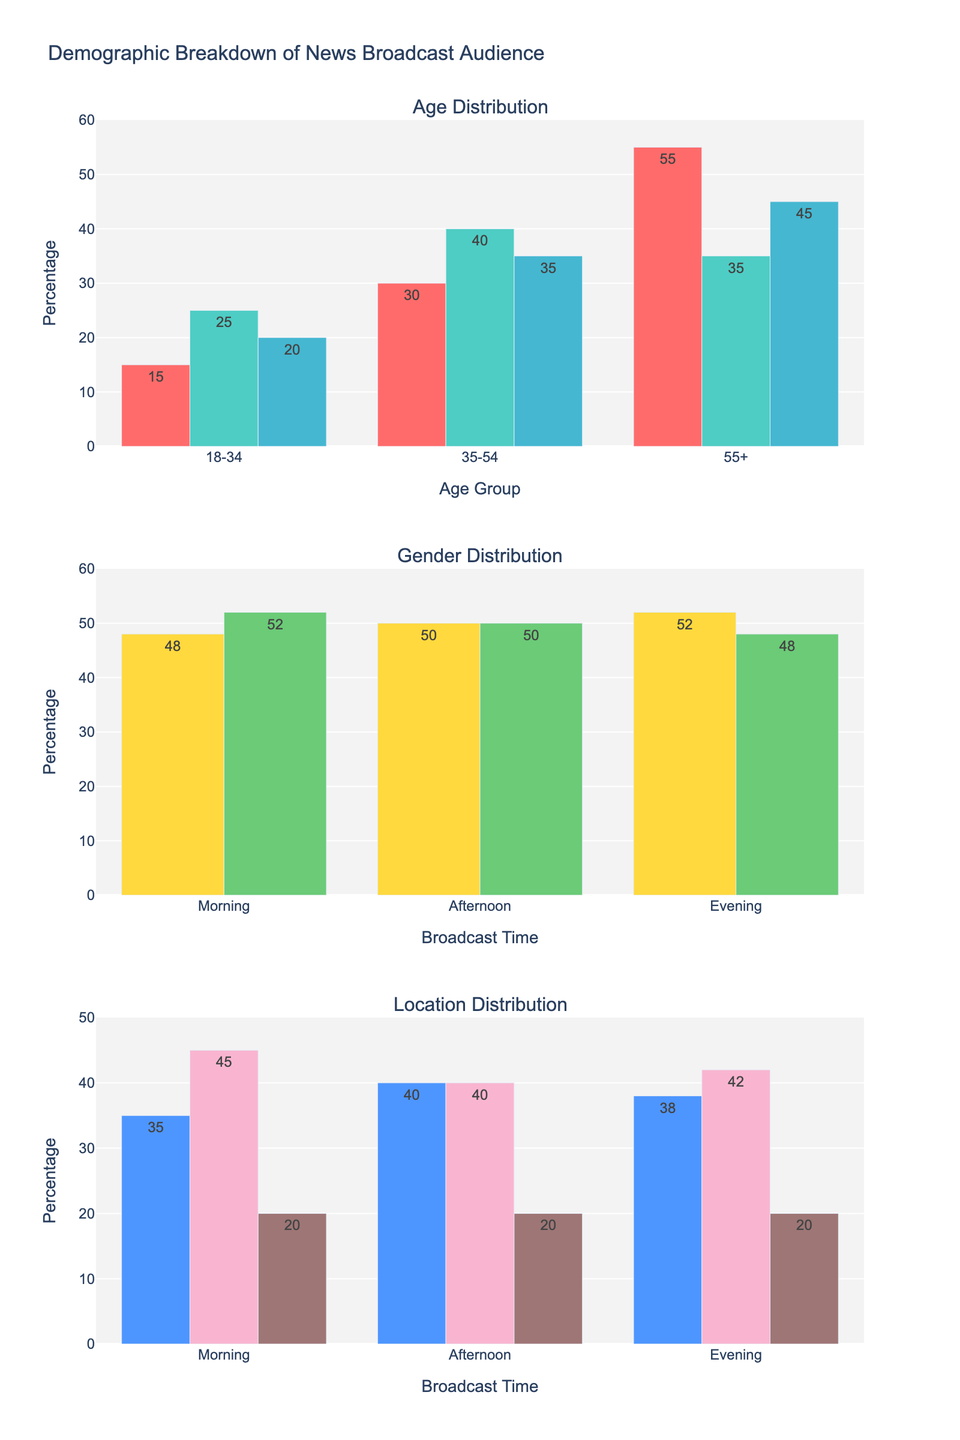What is the percentage of the 18-34 age group in the morning news audience? Look at the first subplot titled "Age Distribution" and locate the bar labeled '18-34' under 'Morning'. The text on top of the bar indicates the percentage.
Answer: 15% What is the total percentage of male viewers across all time slots? Sum the percentages of male viewers from the 'Male' bars in the second subplot titled "Gender Distribution". The values are 48 for Morning, 50 for Afternoon, and 52 for Evening. The total is 48 + 50 + 52 = 150.
Answer: 150% Which time slot has the highest percentage of suburban viewers? Look at the third subplot titled "Location Distribution" and compare the 'Suburban' bars. The morning has 45%, afternoon has 40%, and evening has 42%. The highest value is 45%, which is in the morning.
Answer: Morning How does the percentage of rural viewers compare between morning and evening broadcasts? Find the 'Rural' bars in the third subplot for Morning and Evening. Both morning and evening have a rural viewer percentage of 20%.
Answer: They are equal What is the combined percentage of urban and rural viewers in the afternoon broadcast? Add the percentages of 'Urban' and 'Rural' viewers in the afternoon from the third subplot. Urban is 40%, and Rural is 20%. Therefore, 40 + 20 = 60%.
Answer: 60% 